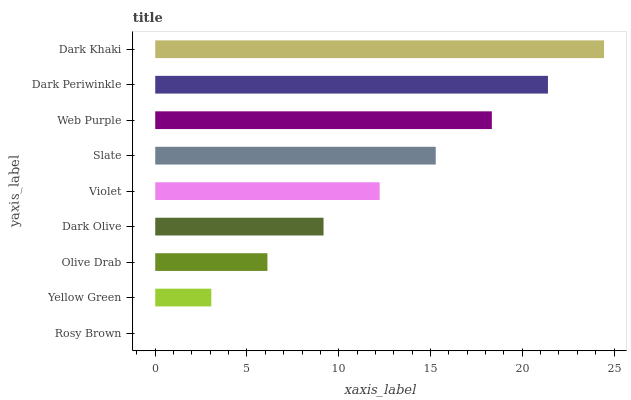Is Rosy Brown the minimum?
Answer yes or no. Yes. Is Dark Khaki the maximum?
Answer yes or no. Yes. Is Yellow Green the minimum?
Answer yes or no. No. Is Yellow Green the maximum?
Answer yes or no. No. Is Yellow Green greater than Rosy Brown?
Answer yes or no. Yes. Is Rosy Brown less than Yellow Green?
Answer yes or no. Yes. Is Rosy Brown greater than Yellow Green?
Answer yes or no. No. Is Yellow Green less than Rosy Brown?
Answer yes or no. No. Is Violet the high median?
Answer yes or no. Yes. Is Violet the low median?
Answer yes or no. Yes. Is Yellow Green the high median?
Answer yes or no. No. Is Dark Khaki the low median?
Answer yes or no. No. 